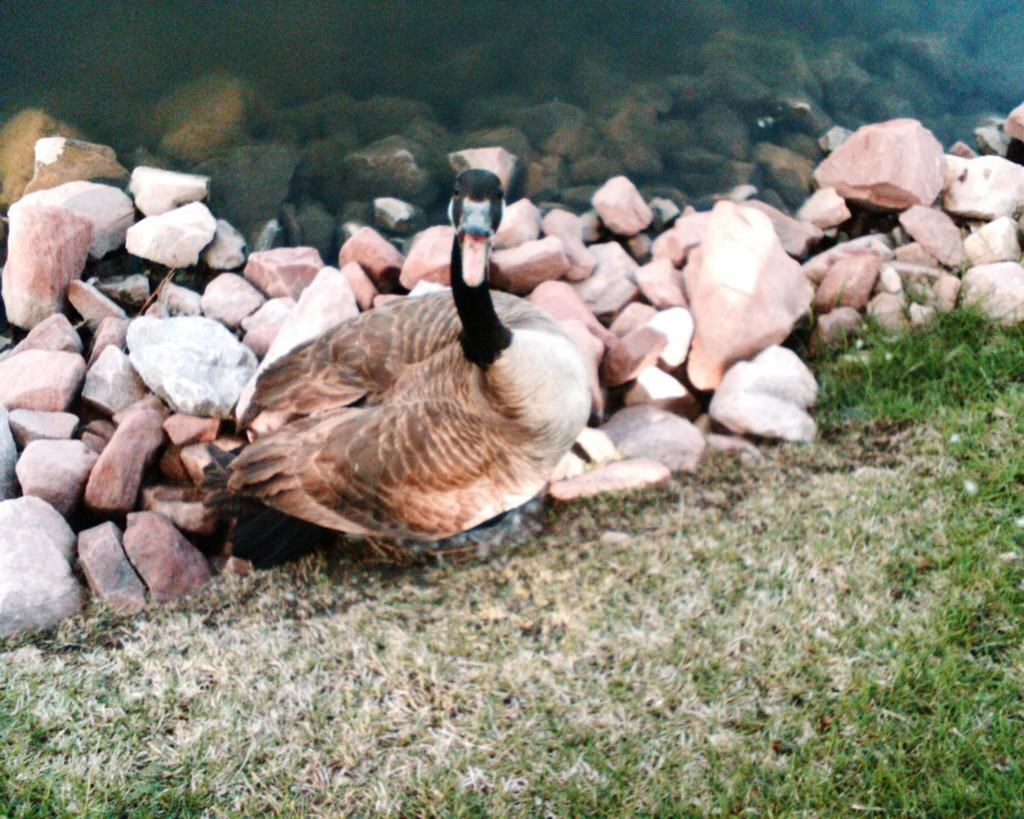What is the primary element in the image? There is water in the image. What other objects or features can be seen in the image? There are rocks, a duck, and grass in the image. What type of receipt can be seen in the image? There is no receipt present in the image. Can you describe the duck's toe in the image? There is no mention of a duck's toe in the image, and ducks do not have toes like humans. 